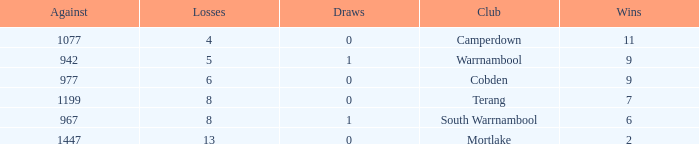What is the draw when the losses were more than 8 and less than 2 wins? None. 